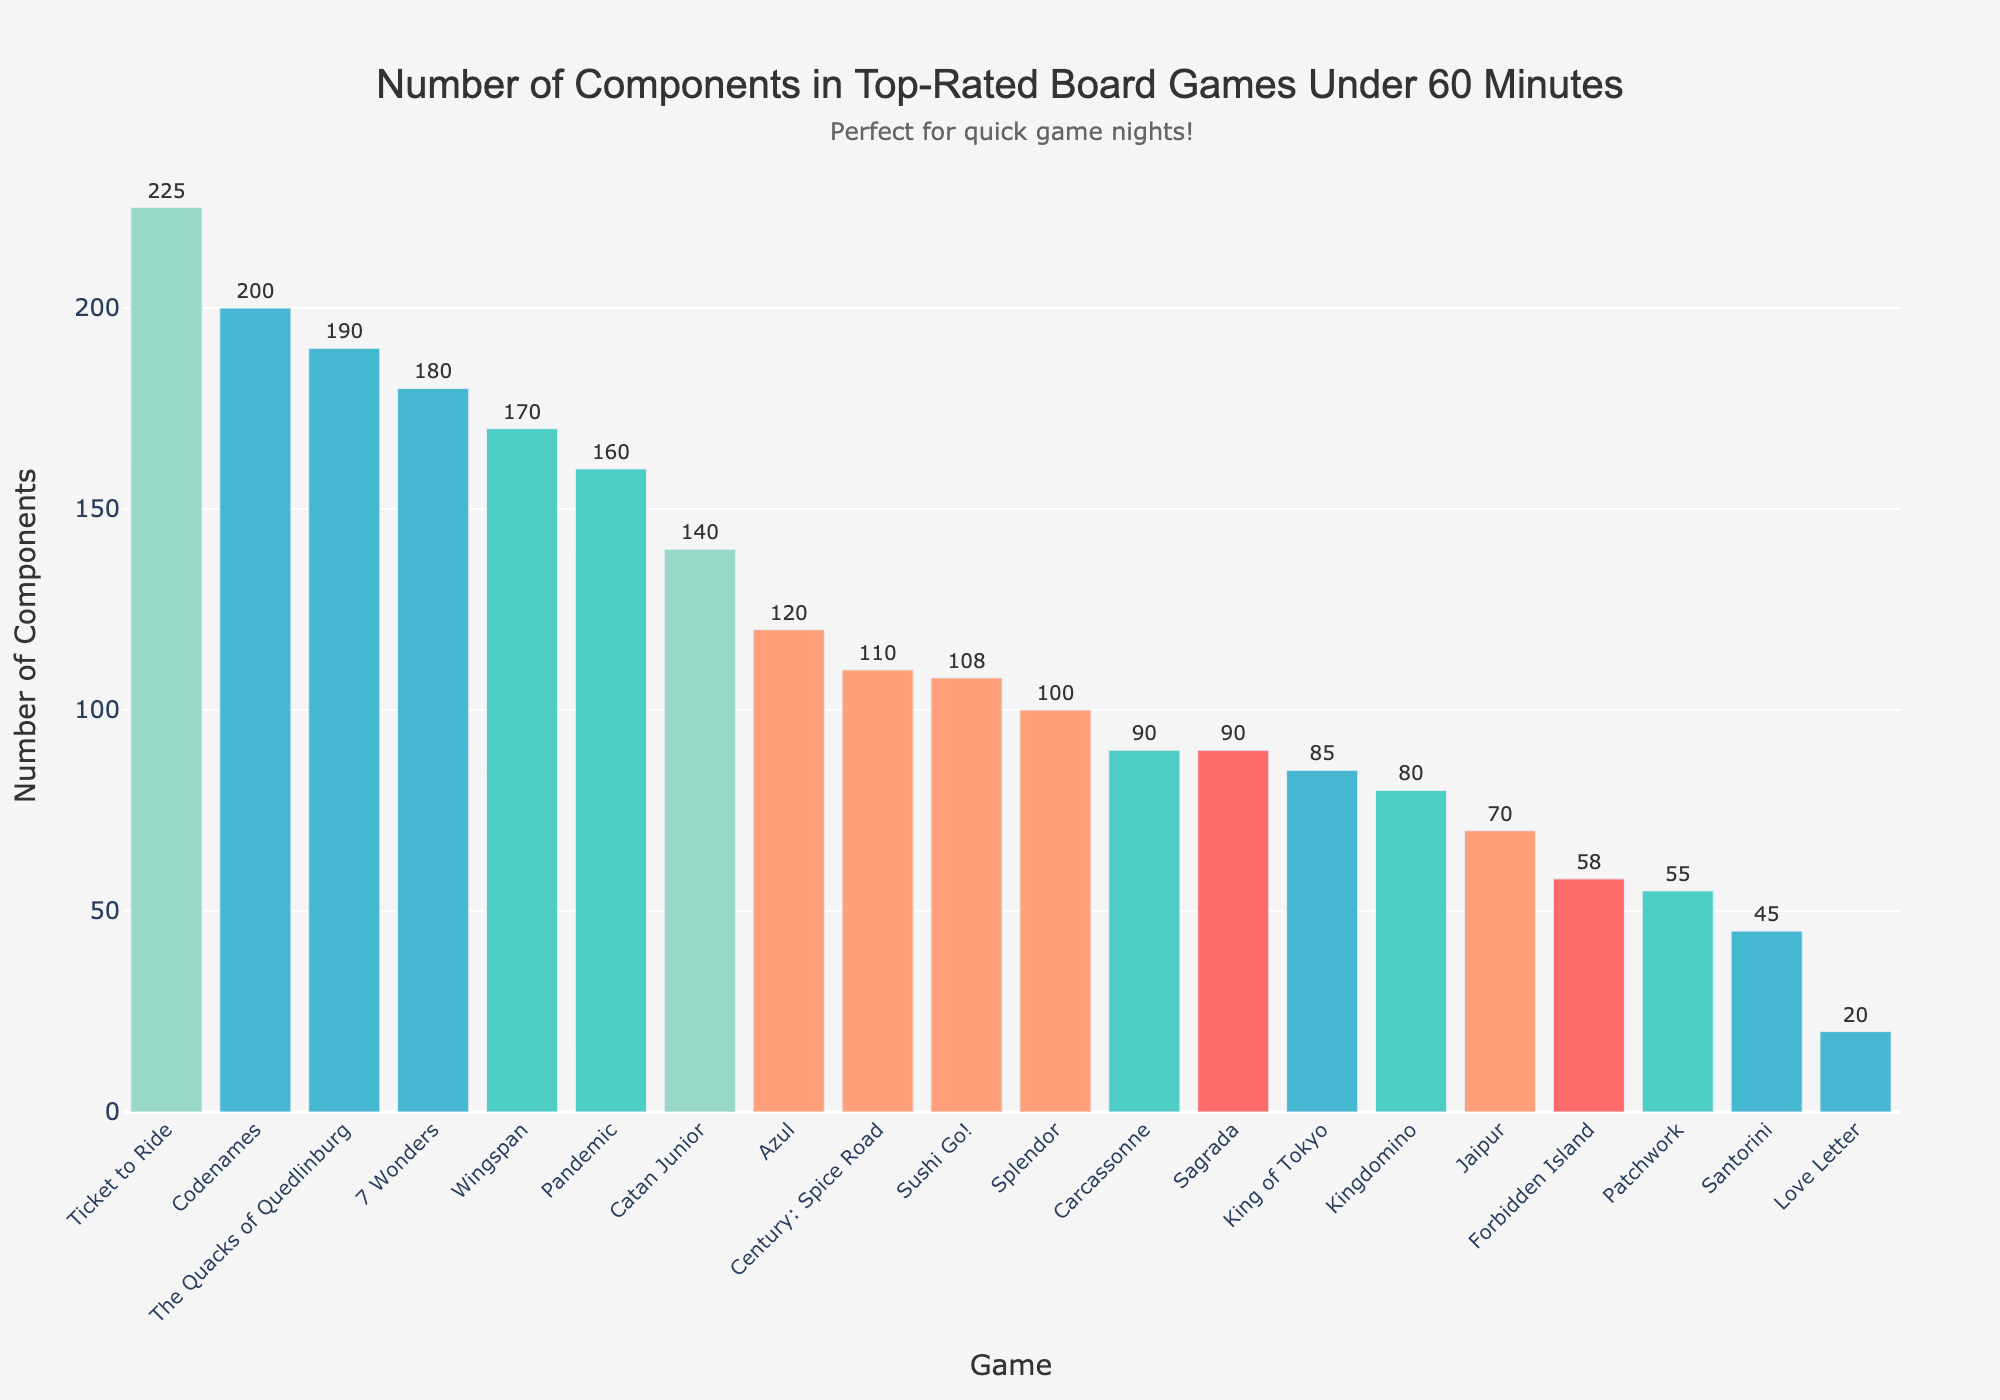What game has the most components? Looking at the height of the bars, Ticket to Ride has the tallest bar, indicating the most components.
Answer: Ticket to Ride Which game has fewer components, Kingdomino or Love Letter? Comparing the heights of the bars for Kingdomino and Love Letter, Love Letter’s bar is shorter.
Answer: Love Letter How many more components does Pandemic have than Carcassonne? Pandemic has 160 components and Carcassonne has 90. Subtracting 90 from 160 gives 70.
Answer: 70 What is the total number of components in Codenames and Azul? Adding the components for Codenames (200) and Azul (120) results in 320.
Answer: 320 Among the games listed, which one has the smallest number of components, and how many does it have? The shortest bar represents Love Letter, which has 20 components.
Answer: Love Letter, 20 Which game has more components: Wingspan or Century: Spice Road? Comparing the heights of the bars, Wingspan has a taller bar than Century: Spice Road.
Answer: Wingspan How many games have more components than Sushi Go!? Sushi Go! has 108 components. Counting the bars with more components, there are 10 games.
Answer: 10 What is the average number of components in Patchwork, Jaipur, and Forbidden Island? Summing the components (Patchwork: 55, Jaipur: 70, Forbidden Island: 58) equals 183. Dividing by 3 results in an average of 61.
Answer: 61 Is the number of components in Carcassonne closer to that of Sagrada or Forbidden Island? Sagrada has 90 components, Forbidden Island has 58, and Carcassonne also has 90. Carcassonne is the same as Sagrada.
Answer: Sagrada Which game has just over half the components of 7 Wonders? 7 Wonders has 180 components, half of which is 90. The game with slightly over 90 components is Sagrada, also with exactly 90 components.
Answer: Sagrada 